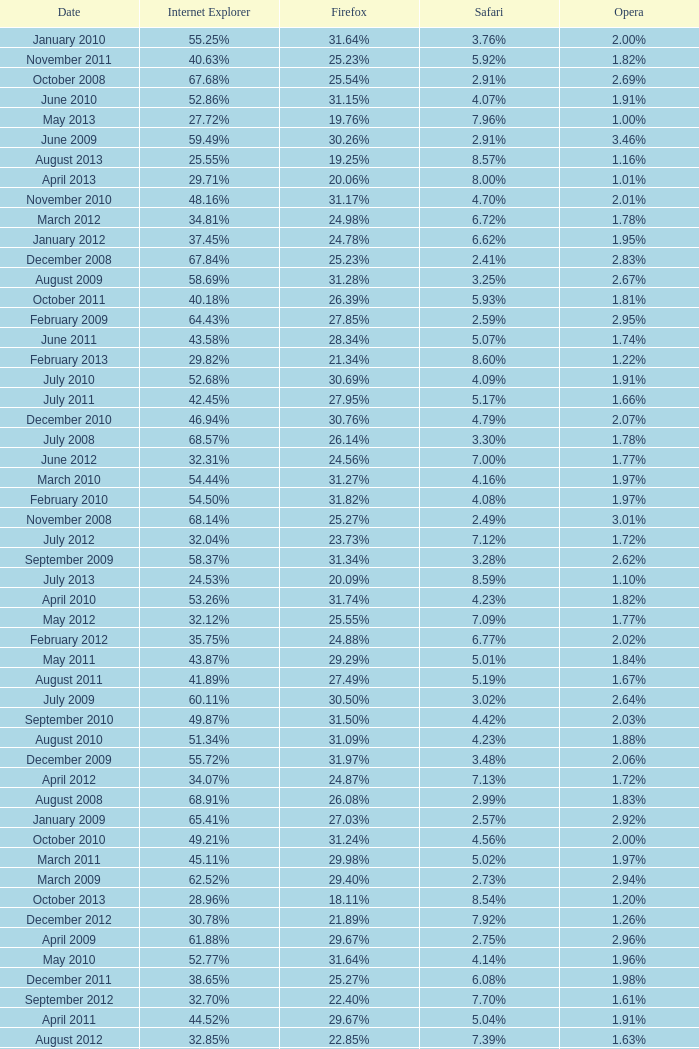What percentage of browsers were using Internet Explorer during the period in which 27.85% were using Firefox? 64.43%. 